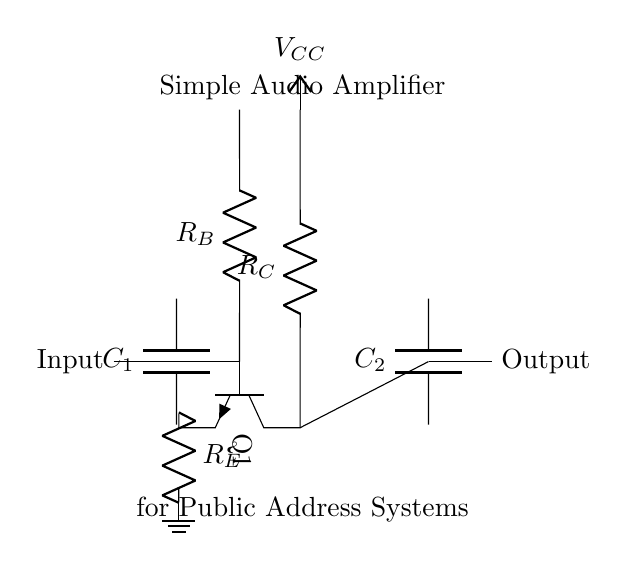What is the type of transistor used in this circuit? The circuit uses an NPN transistor, which is indicated by the symbol in the diagram. The labeling of Q1 shows it as a transistor and the specific arrangement further defines it as NPN.
Answer: NPN What is the function of capacitor C1? Capacitor C1 is used for coupling the input signal to the transistor base while blocking any DC component, thus allowing only the AC signal to pass through. This is a common function in amplifier circuits.
Answer: Coupling What is the purpose of resistor R_B? Resistor R_B is used for biasing the base of the transistor. It sets the operating point of the transistor, ensuring it remains in the active region for appropriate amplification of signals.
Answer: Biasing How many capacitors are in the circuit? There are two capacitors in the circuit, C1 and C2, which are used for coupling at the input and output stages, respectively.
Answer: Two What does V_CC represent in this circuit? V_CC represents the supply voltage for the circuit, providing the necessary power to the transistor for proper operation and amplification of the audio signal.
Answer: Supply voltage Why is there a coupling capacitor C2 at the output? Capacitor C2 is used to block any DC component from being fed into the output load while allowing the amplified AC audio signal to pass through, ensuring that only the desired audio signal reaches the output.
Answer: Block DC 